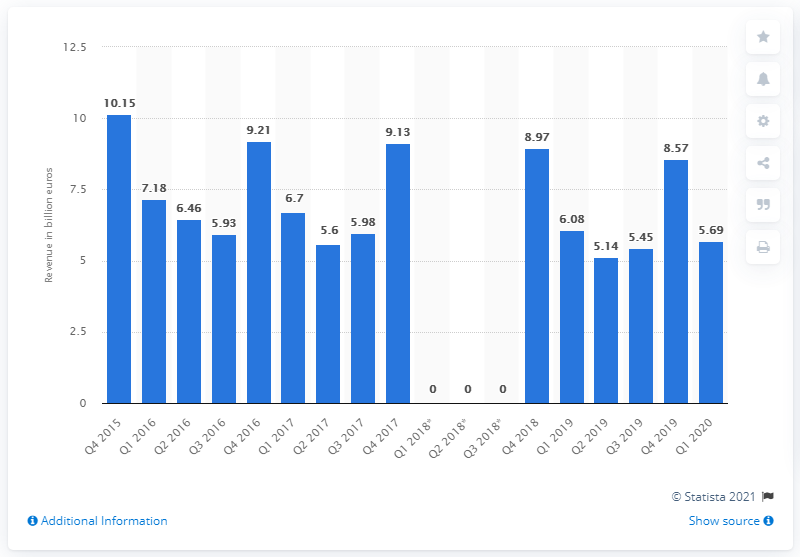List a handful of essential elements in this visual. In the fourth quarter of 2015, the revenues from consumer electronics in Western Europe totaled 10.15 billion euros. In the first quarter of 2020, the revenue of CE was 5.69 million. 